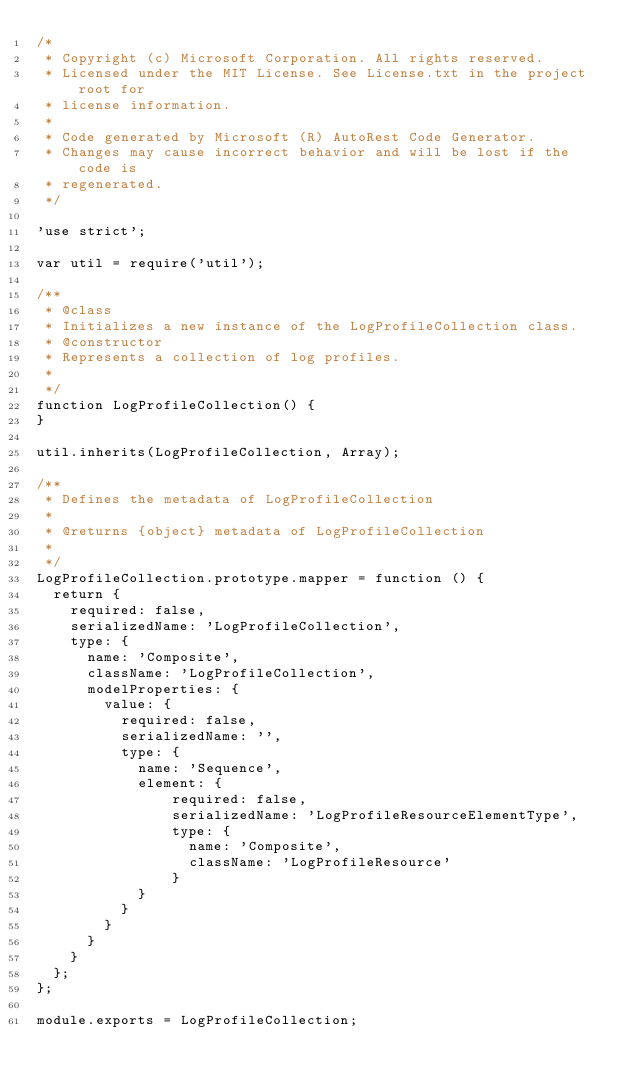Convert code to text. <code><loc_0><loc_0><loc_500><loc_500><_JavaScript_>/*
 * Copyright (c) Microsoft Corporation. All rights reserved.
 * Licensed under the MIT License. See License.txt in the project root for
 * license information.
 * 
 * Code generated by Microsoft (R) AutoRest Code Generator.
 * Changes may cause incorrect behavior and will be lost if the code is
 * regenerated.
 */

'use strict';

var util = require('util');

/**
 * @class
 * Initializes a new instance of the LogProfileCollection class.
 * @constructor
 * Represents a collection of log profiles.
 *
 */
function LogProfileCollection() {
}

util.inherits(LogProfileCollection, Array);

/**
 * Defines the metadata of LogProfileCollection
 *
 * @returns {object} metadata of LogProfileCollection
 *
 */
LogProfileCollection.prototype.mapper = function () {
  return {
    required: false,
    serializedName: 'LogProfileCollection',
    type: {
      name: 'Composite',
      className: 'LogProfileCollection',
      modelProperties: {
        value: {
          required: false,
          serializedName: '',
          type: {
            name: 'Sequence',
            element: {
                required: false,
                serializedName: 'LogProfileResourceElementType',
                type: {
                  name: 'Composite',
                  className: 'LogProfileResource'
                }
            }
          }
        }
      }
    }
  };
};

module.exports = LogProfileCollection;
</code> 